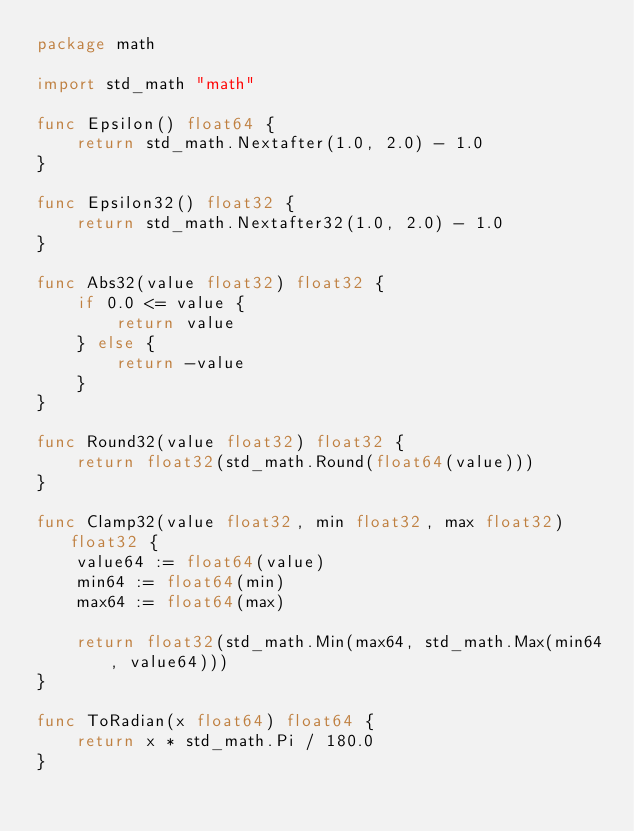Convert code to text. <code><loc_0><loc_0><loc_500><loc_500><_Go_>package math

import std_math "math"

func Epsilon() float64 {
	return std_math.Nextafter(1.0, 2.0) - 1.0
}

func Epsilon32() float32 {
	return std_math.Nextafter32(1.0, 2.0) - 1.0
}

func Abs32(value float32) float32 {
	if 0.0 <= value {
		return value
	} else {
		return -value
	}
}

func Round32(value float32) float32 {
	return float32(std_math.Round(float64(value)))
}

func Clamp32(value float32, min float32, max float32) float32 {
	value64 := float64(value)
	min64 := float64(min)
	max64 := float64(max)

	return float32(std_math.Min(max64, std_math.Max(min64, value64)))
}

func ToRadian(x float64) float64 {
	return x * std_math.Pi / 180.0
}
</code> 